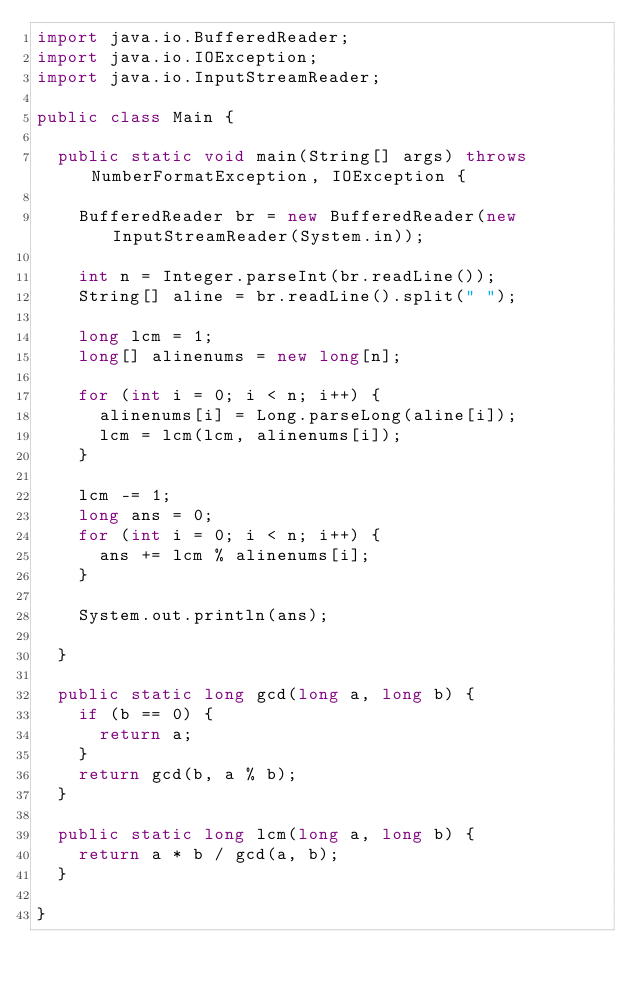Convert code to text. <code><loc_0><loc_0><loc_500><loc_500><_Java_>import java.io.BufferedReader;
import java.io.IOException;
import java.io.InputStreamReader;

public class Main {

	public static void main(String[] args) throws NumberFormatException, IOException {

		BufferedReader br = new BufferedReader(new InputStreamReader(System.in));

		int n = Integer.parseInt(br.readLine());
		String[] aline = br.readLine().split(" ");

		long lcm = 1;
		long[] alinenums = new long[n];

		for (int i = 0; i < n; i++) {
			alinenums[i] = Long.parseLong(aline[i]);
			lcm = lcm(lcm, alinenums[i]);
		}

		lcm -= 1;
		long ans = 0;
		for (int i = 0; i < n; i++) {
			ans += lcm % alinenums[i];
		}

		System.out.println(ans);

	}

	public static long gcd(long a, long b) {
		if (b == 0) {
			return a;
		}
		return gcd(b, a % b);
	}

	public static long lcm(long a, long b) {
		return a * b / gcd(a, b);
	}

}</code> 